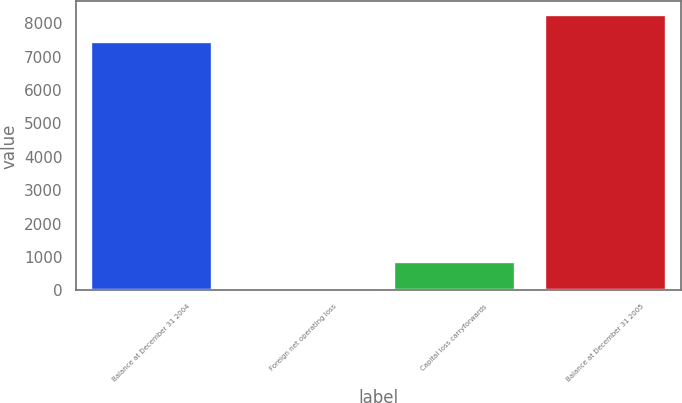Convert chart to OTSL. <chart><loc_0><loc_0><loc_500><loc_500><bar_chart><fcel>Balance at December 31 2004<fcel>Foreign net operating loss<fcel>Capital loss carryforwards<fcel>Balance at December 31 2005<nl><fcel>7429<fcel>39<fcel>850<fcel>8240<nl></chart> 